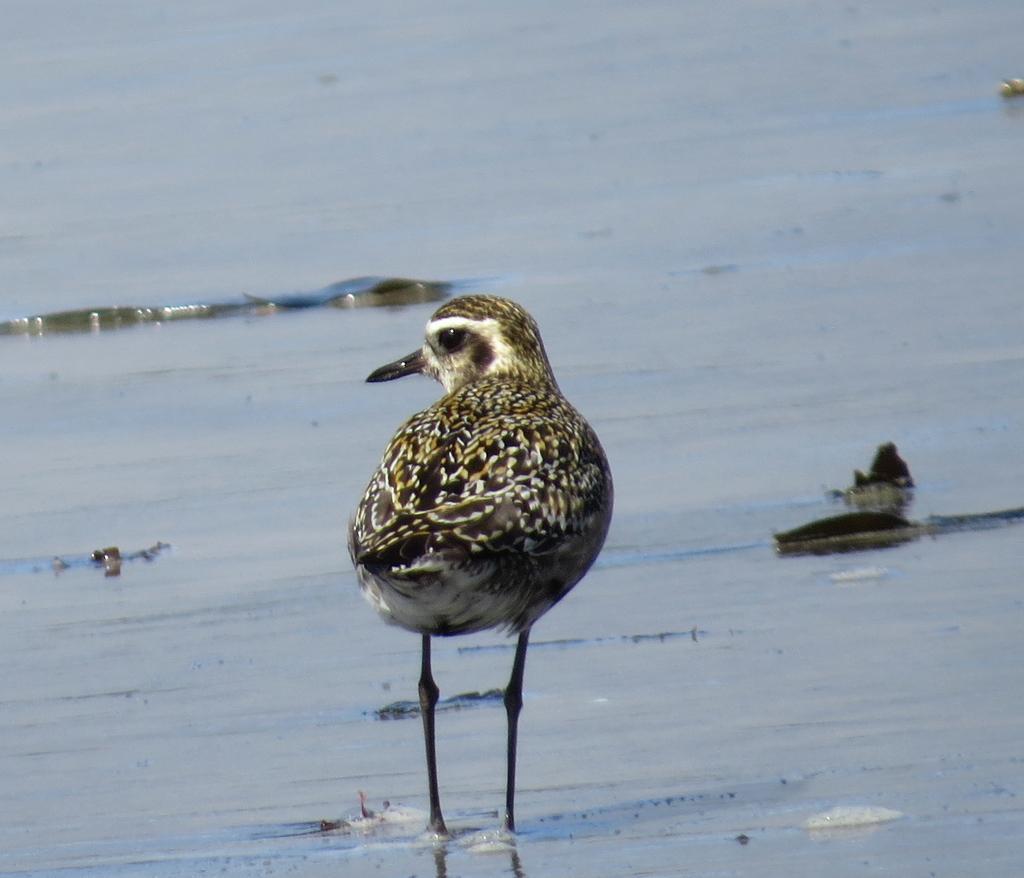Can you describe this image briefly? In this picture we can see a bird in water. 